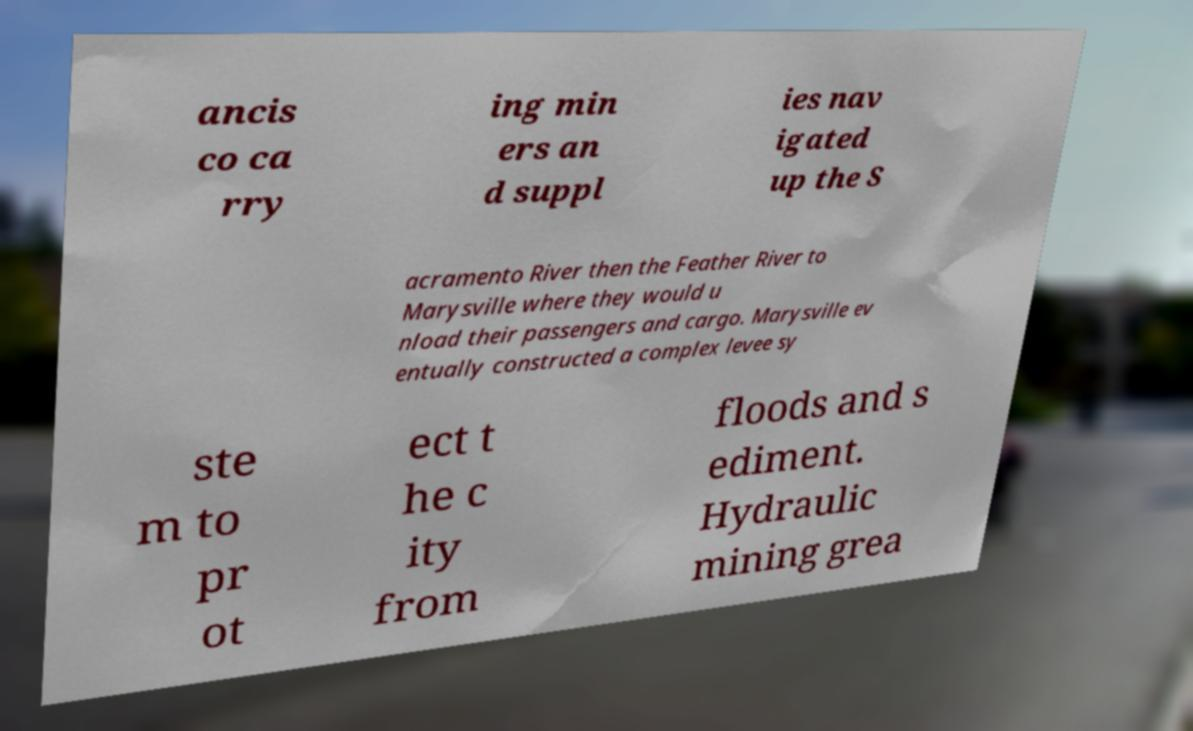Could you assist in decoding the text presented in this image and type it out clearly? ancis co ca rry ing min ers an d suppl ies nav igated up the S acramento River then the Feather River to Marysville where they would u nload their passengers and cargo. Marysville ev entually constructed a complex levee sy ste m to pr ot ect t he c ity from floods and s ediment. Hydraulic mining grea 